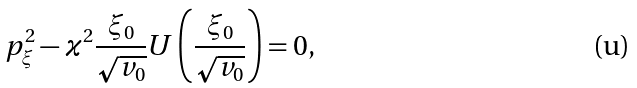Convert formula to latex. <formula><loc_0><loc_0><loc_500><loc_500>p ^ { 2 } _ { \xi } - \varkappa ^ { 2 } \frac { \xi _ { 0 } } { \sqrt { v _ { 0 } } } U \left ( \frac { \xi _ { 0 } } { \sqrt { v _ { 0 } } } \right ) = 0 ,</formula> 